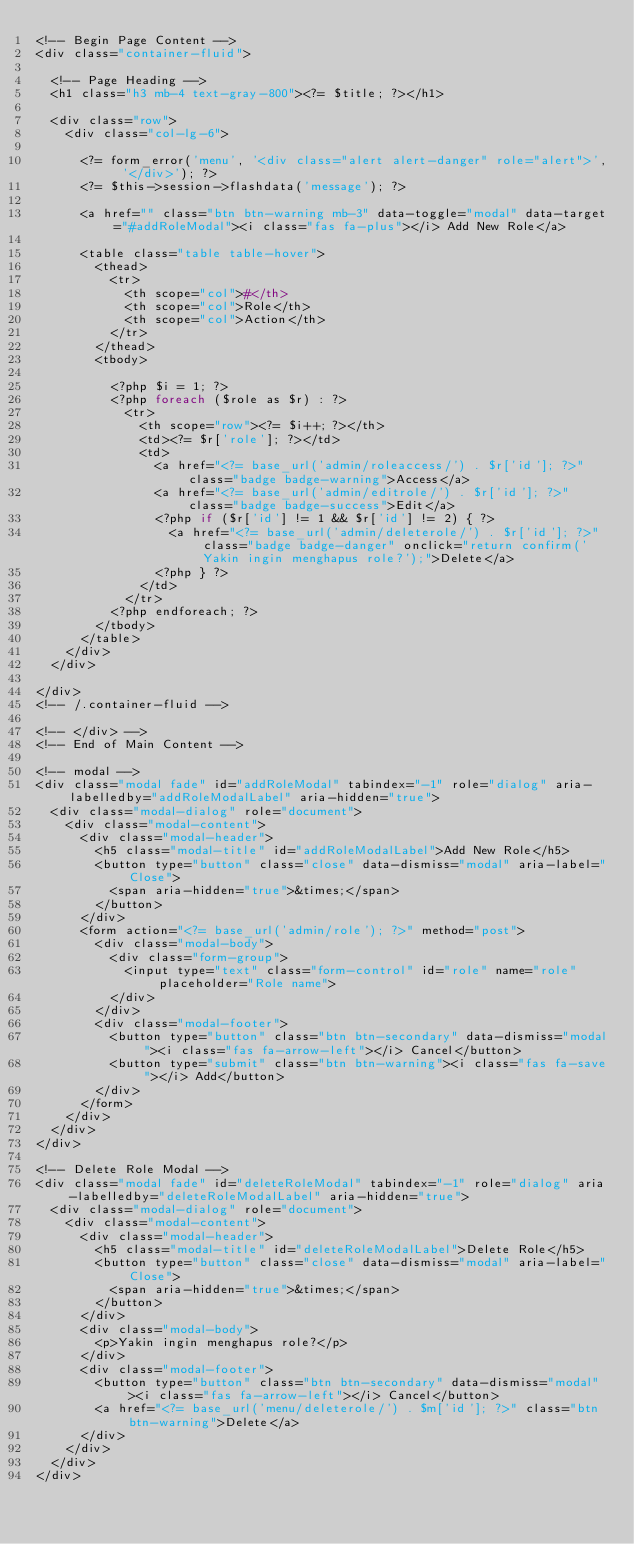Convert code to text. <code><loc_0><loc_0><loc_500><loc_500><_PHP_><!-- Begin Page Content -->
<div class="container-fluid">

  <!-- Page Heading -->
  <h1 class="h3 mb-4 text-gray-800"><?= $title; ?></h1>

  <div class="row">
    <div class="col-lg-6">

      <?= form_error('menu', '<div class="alert alert-danger" role="alert">', '</div>'); ?>
      <?= $this->session->flashdata('message'); ?>

      <a href="" class="btn btn-warning mb-3" data-toggle="modal" data-target="#addRoleModal"><i class="fas fa-plus"></i> Add New Role</a>

      <table class="table table-hover">
        <thead>
          <tr>
            <th scope="col">#</th>
            <th scope="col">Role</th>
            <th scope="col">Action</th>
          </tr>
        </thead>
        <tbody>

          <?php $i = 1; ?>
          <?php foreach ($role as $r) : ?>
            <tr>
              <th scope="row"><?= $i++; ?></th>
              <td><?= $r['role']; ?></td>
              <td>
                <a href="<?= base_url('admin/roleaccess/') . $r['id']; ?>" class="badge badge-warning">Access</a>
                <a href="<?= base_url('admin/editrole/') . $r['id']; ?>" class="badge badge-success">Edit</a>
                <?php if ($r['id'] != 1 && $r['id'] != 2) { ?>
                  <a href="<?= base_url('admin/deleterole/') . $r['id']; ?>" class="badge badge-danger" onclick="return confirm('Yakin ingin menghapus role?');">Delete</a>
                <?php } ?>
              </td>
            </tr>
          <?php endforeach; ?>
        </tbody>
      </table>
    </div>
  </div>

</div>
<!-- /.container-fluid -->

<!-- </div> -->
<!-- End of Main Content -->

<!-- modal -->
<div class="modal fade" id="addRoleModal" tabindex="-1" role="dialog" aria-labelledby="addRoleModalLabel" aria-hidden="true">
  <div class="modal-dialog" role="document">
    <div class="modal-content">
      <div class="modal-header">
        <h5 class="modal-title" id="addRoleModalLabel">Add New Role</h5>
        <button type="button" class="close" data-dismiss="modal" aria-label="Close">
          <span aria-hidden="true">&times;</span>
        </button>
      </div>
      <form action="<?= base_url('admin/role'); ?>" method="post">
        <div class="modal-body">
          <div class="form-group">
            <input type="text" class="form-control" id="role" name="role" placeholder="Role name">
          </div>
        </div>
        <div class="modal-footer">
          <button type="button" class="btn btn-secondary" data-dismiss="modal"><i class="fas fa-arrow-left"></i> Cancel</button>
          <button type="submit" class="btn btn-warning"><i class="fas fa-save"></i> Add</button>
        </div>
      </form>
    </div>
  </div>
</div>

<!-- Delete Role Modal -->
<div class="modal fade" id="deleteRoleModal" tabindex="-1" role="dialog" aria-labelledby="deleteRoleModalLabel" aria-hidden="true">
  <div class="modal-dialog" role="document">
    <div class="modal-content">
      <div class="modal-header">
        <h5 class="modal-title" id="deleteRoleModalLabel">Delete Role</h5>
        <button type="button" class="close" data-dismiss="modal" aria-label="Close">
          <span aria-hidden="true">&times;</span>
        </button>
      </div>
      <div class="modal-body">
        <p>Yakin ingin menghapus role?</p>
      </div>
      <div class="modal-footer">
        <button type="button" class="btn btn-secondary" data-dismiss="modal"><i class="fas fa-arrow-left"></i> Cancel</button>
        <a href="<?= base_url('menu/deleterole/') . $m['id']; ?>" class="btn btn-warning">Delete</a>
      </div>
    </div>
  </div>
</div></code> 